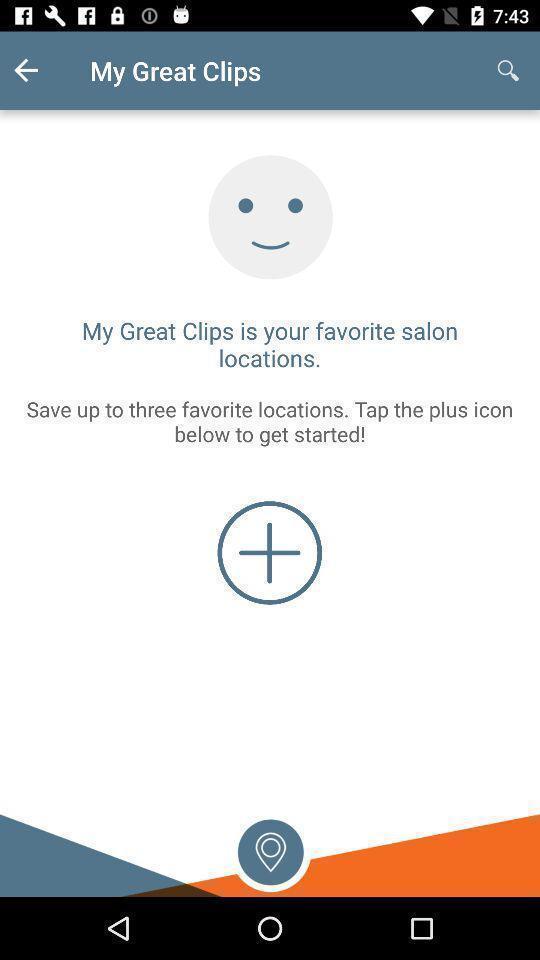Give me a summary of this screen capture. Screen showing my great clips page. 